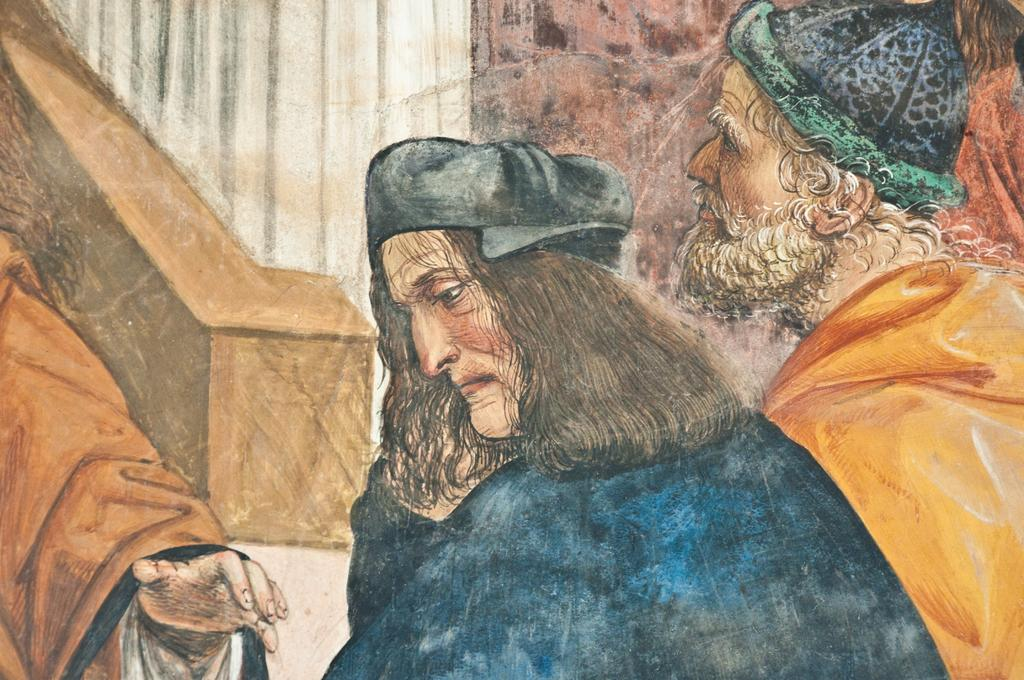What is the main subject of the image? The main subject of the image is a painting. What is shown in the painting? The painting depicts three persons. Where is the painting located in the image? The painting is on an object. Can you tell me how many tomatoes are visible in the alley in the image? There is no alley or tomatoes present in the image; it features a painting of three persons. 